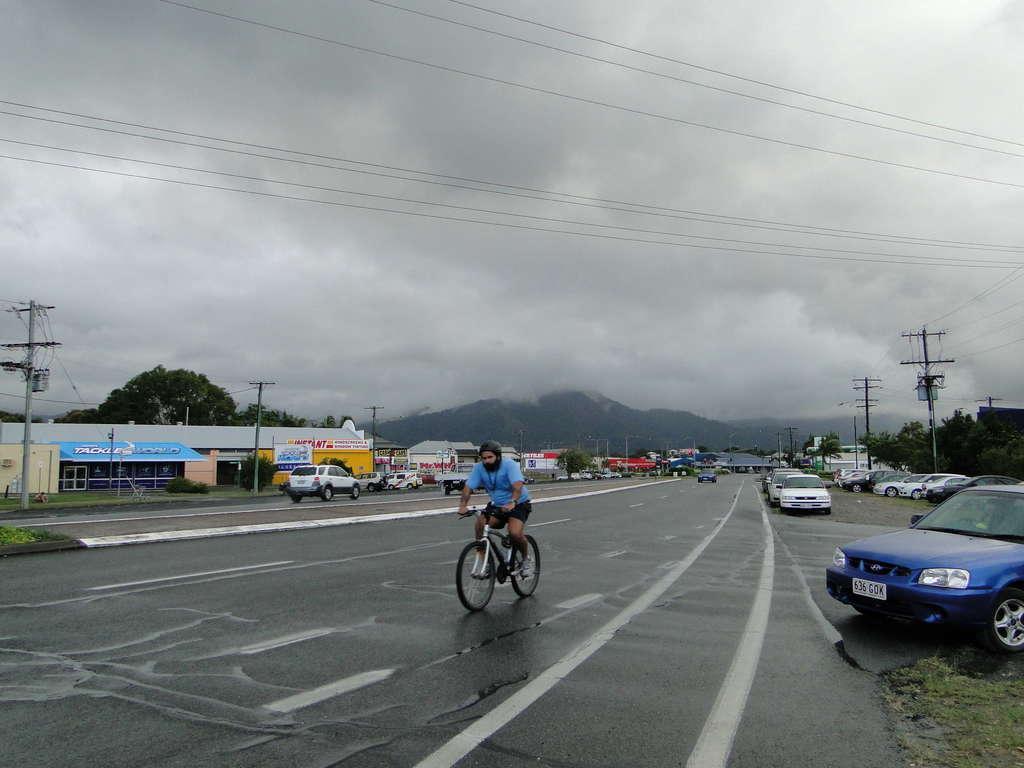Describe this image in one or two sentences. In this image there is a person riding a bicycle on the road, and there are vehicles, shops, trees, hills, poles, and in the background there is sky. 